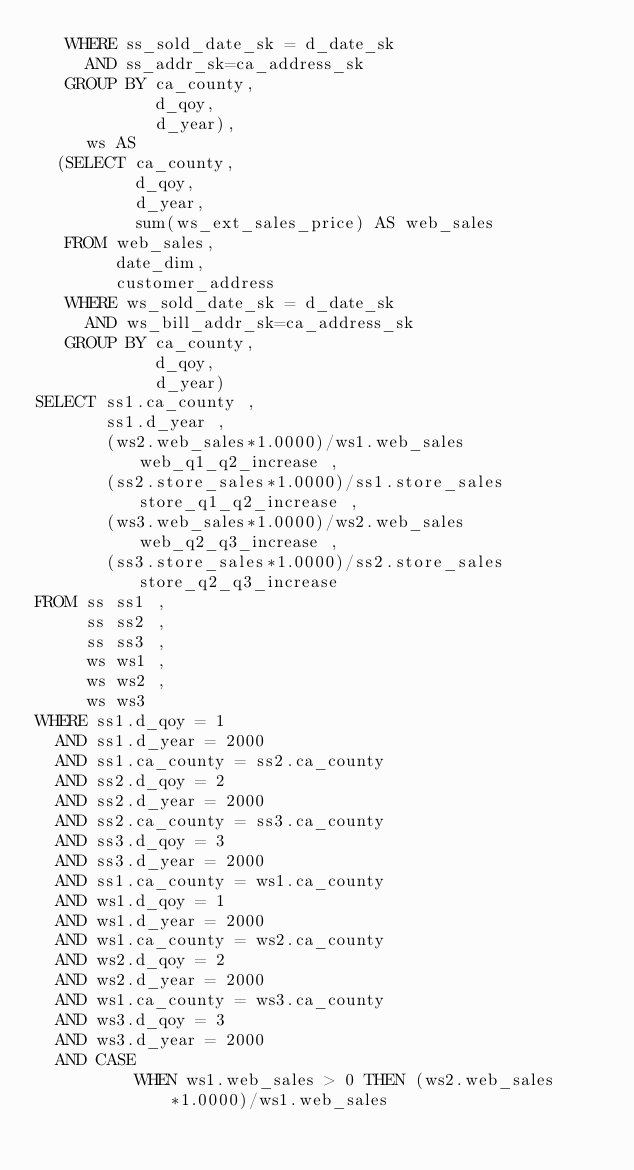Convert code to text. <code><loc_0><loc_0><loc_500><loc_500><_SQL_>   WHERE ss_sold_date_sk = d_date_sk
     AND ss_addr_sk=ca_address_sk
   GROUP BY ca_county,
            d_qoy,
            d_year),
     ws AS
  (SELECT ca_county,
          d_qoy,
          d_year,
          sum(ws_ext_sales_price) AS web_sales
   FROM web_sales,
        date_dim,
        customer_address
   WHERE ws_sold_date_sk = d_date_sk
     AND ws_bill_addr_sk=ca_address_sk
   GROUP BY ca_county,
            d_qoy,
            d_year)
SELECT ss1.ca_county ,
       ss1.d_year ,
       (ws2.web_sales*1.0000)/ws1.web_sales web_q1_q2_increase ,
       (ss2.store_sales*1.0000)/ss1.store_sales store_q1_q2_increase ,
       (ws3.web_sales*1.0000)/ws2.web_sales web_q2_q3_increase ,
       (ss3.store_sales*1.0000)/ss2.store_sales store_q2_q3_increase
FROM ss ss1 ,
     ss ss2 ,
     ss ss3 ,
     ws ws1 ,
     ws ws2 ,
     ws ws3
WHERE ss1.d_qoy = 1
  AND ss1.d_year = 2000
  AND ss1.ca_county = ss2.ca_county
  AND ss2.d_qoy = 2
  AND ss2.d_year = 2000
  AND ss2.ca_county = ss3.ca_county
  AND ss3.d_qoy = 3
  AND ss3.d_year = 2000
  AND ss1.ca_county = ws1.ca_county
  AND ws1.d_qoy = 1
  AND ws1.d_year = 2000
  AND ws1.ca_county = ws2.ca_county
  AND ws2.d_qoy = 2
  AND ws2.d_year = 2000
  AND ws1.ca_county = ws3.ca_county
  AND ws3.d_qoy = 3
  AND ws3.d_year = 2000
  AND CASE
          WHEN ws1.web_sales > 0 THEN (ws2.web_sales*1.0000)/ws1.web_sales</code> 